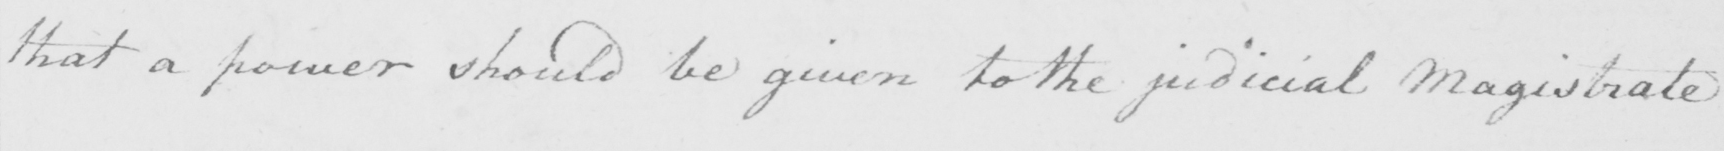What does this handwritten line say? that a power should be given to the judicial Magistrate 